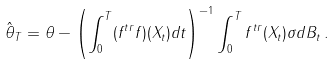Convert formula to latex. <formula><loc_0><loc_0><loc_500><loc_500>\hat { \theta } _ { T } = \theta - \left ( \int _ { 0 } ^ { T } ( f ^ { t r } f ) ( X _ { t } ) d t \right ) ^ { - 1 } \int _ { 0 } ^ { T } f ^ { t r } ( X _ { t } ) \sigma d B _ { t } \, .</formula> 